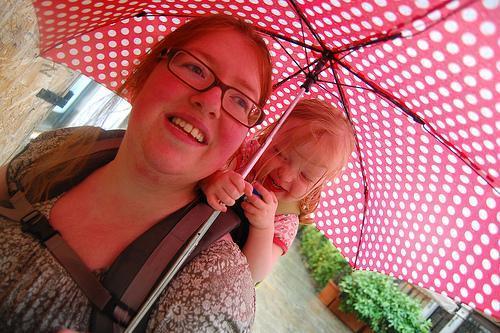How many people are there?
Give a very brief answer. 2. 